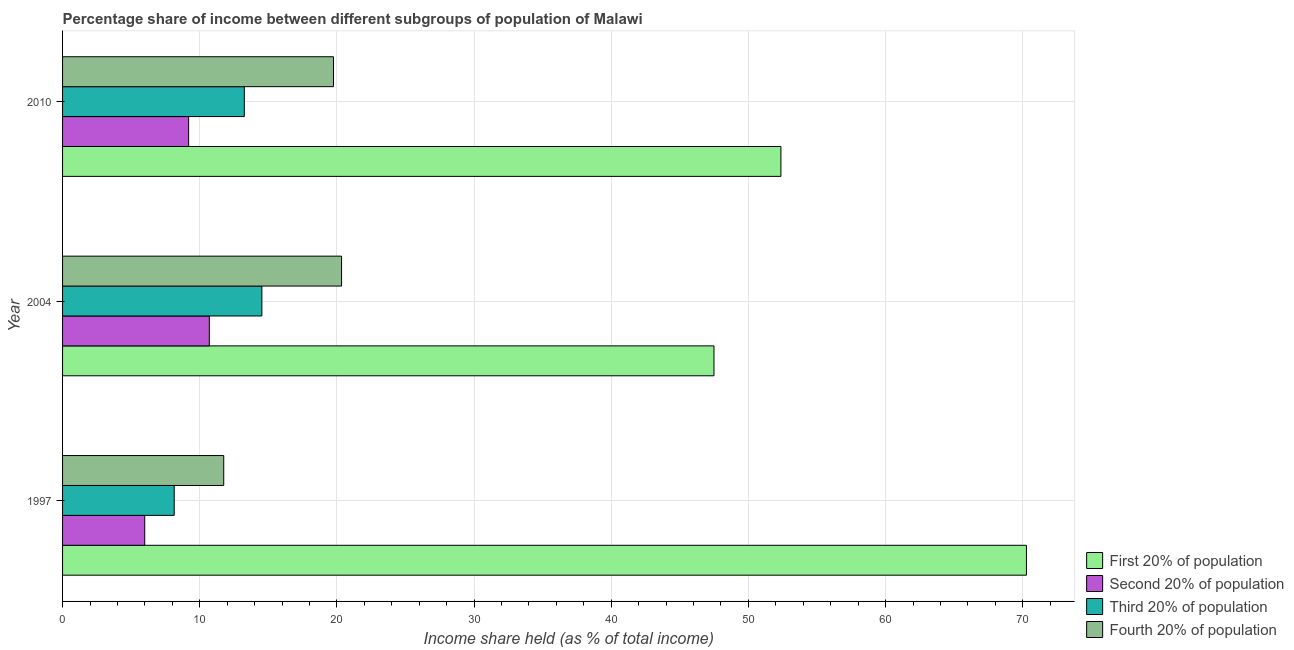How many different coloured bars are there?
Your response must be concise. 4. How many groups of bars are there?
Give a very brief answer. 3. How many bars are there on the 2nd tick from the top?
Offer a terse response. 4. How many bars are there on the 3rd tick from the bottom?
Your answer should be compact. 4. What is the share of the income held by fourth 20% of the population in 2004?
Your answer should be very brief. 20.34. Across all years, what is the maximum share of the income held by third 20% of the population?
Give a very brief answer. 14.53. Across all years, what is the minimum share of the income held by third 20% of the population?
Your answer should be very brief. 8.14. In which year was the share of the income held by first 20% of the population maximum?
Make the answer very short. 1997. What is the total share of the income held by first 20% of the population in the graph?
Ensure brevity in your answer.  170.13. What is the difference between the share of the income held by fourth 20% of the population in 2004 and that in 2010?
Ensure brevity in your answer.  0.59. What is the difference between the share of the income held by fourth 20% of the population in 1997 and the share of the income held by second 20% of the population in 2010?
Make the answer very short. 2.56. What is the average share of the income held by third 20% of the population per year?
Offer a terse response. 11.97. In the year 2010, what is the difference between the share of the income held by fourth 20% of the population and share of the income held by first 20% of the population?
Give a very brief answer. -32.62. What is the ratio of the share of the income held by fourth 20% of the population in 1997 to that in 2010?
Keep it short and to the point. 0.59. Is the share of the income held by first 20% of the population in 1997 less than that in 2010?
Your response must be concise. No. Is the difference between the share of the income held by fourth 20% of the population in 2004 and 2010 greater than the difference between the share of the income held by first 20% of the population in 2004 and 2010?
Offer a very short reply. Yes. What is the difference between the highest and the second highest share of the income held by third 20% of the population?
Your response must be concise. 1.28. What is the difference between the highest and the lowest share of the income held by fourth 20% of the population?
Ensure brevity in your answer.  8.59. Is the sum of the share of the income held by third 20% of the population in 2004 and 2010 greater than the maximum share of the income held by first 20% of the population across all years?
Your answer should be very brief. No. Is it the case that in every year, the sum of the share of the income held by fourth 20% of the population and share of the income held by third 20% of the population is greater than the sum of share of the income held by first 20% of the population and share of the income held by second 20% of the population?
Provide a succinct answer. No. What does the 4th bar from the top in 2010 represents?
Provide a short and direct response. First 20% of population. What does the 4th bar from the bottom in 2010 represents?
Your response must be concise. Fourth 20% of population. Are all the bars in the graph horizontal?
Your answer should be very brief. Yes. Does the graph contain grids?
Offer a very short reply. Yes. Where does the legend appear in the graph?
Offer a terse response. Bottom right. How are the legend labels stacked?
Offer a very short reply. Vertical. What is the title of the graph?
Your answer should be compact. Percentage share of income between different subgroups of population of Malawi. Does "France" appear as one of the legend labels in the graph?
Offer a terse response. No. What is the label or title of the X-axis?
Your answer should be very brief. Income share held (as % of total income). What is the Income share held (as % of total income) in First 20% of population in 1997?
Your response must be concise. 70.27. What is the Income share held (as % of total income) in Second 20% of population in 1997?
Offer a very short reply. 5.99. What is the Income share held (as % of total income) in Third 20% of population in 1997?
Offer a very short reply. 8.14. What is the Income share held (as % of total income) of Fourth 20% of population in 1997?
Offer a terse response. 11.75. What is the Income share held (as % of total income) of First 20% of population in 2004?
Keep it short and to the point. 47.49. What is the Income share held (as % of total income) in Second 20% of population in 2004?
Offer a terse response. 10.7. What is the Income share held (as % of total income) in Third 20% of population in 2004?
Keep it short and to the point. 14.53. What is the Income share held (as % of total income) of Fourth 20% of population in 2004?
Ensure brevity in your answer.  20.34. What is the Income share held (as % of total income) in First 20% of population in 2010?
Offer a very short reply. 52.37. What is the Income share held (as % of total income) in Second 20% of population in 2010?
Ensure brevity in your answer.  9.19. What is the Income share held (as % of total income) of Third 20% of population in 2010?
Offer a terse response. 13.25. What is the Income share held (as % of total income) of Fourth 20% of population in 2010?
Provide a succinct answer. 19.75. Across all years, what is the maximum Income share held (as % of total income) in First 20% of population?
Offer a terse response. 70.27. Across all years, what is the maximum Income share held (as % of total income) of Third 20% of population?
Provide a short and direct response. 14.53. Across all years, what is the maximum Income share held (as % of total income) of Fourth 20% of population?
Offer a very short reply. 20.34. Across all years, what is the minimum Income share held (as % of total income) of First 20% of population?
Keep it short and to the point. 47.49. Across all years, what is the minimum Income share held (as % of total income) in Second 20% of population?
Your answer should be compact. 5.99. Across all years, what is the minimum Income share held (as % of total income) of Third 20% of population?
Your response must be concise. 8.14. Across all years, what is the minimum Income share held (as % of total income) in Fourth 20% of population?
Make the answer very short. 11.75. What is the total Income share held (as % of total income) in First 20% of population in the graph?
Give a very brief answer. 170.13. What is the total Income share held (as % of total income) in Second 20% of population in the graph?
Your answer should be very brief. 25.88. What is the total Income share held (as % of total income) in Third 20% of population in the graph?
Your answer should be compact. 35.92. What is the total Income share held (as % of total income) in Fourth 20% of population in the graph?
Ensure brevity in your answer.  51.84. What is the difference between the Income share held (as % of total income) of First 20% of population in 1997 and that in 2004?
Provide a succinct answer. 22.78. What is the difference between the Income share held (as % of total income) of Second 20% of population in 1997 and that in 2004?
Your answer should be very brief. -4.71. What is the difference between the Income share held (as % of total income) of Third 20% of population in 1997 and that in 2004?
Your answer should be compact. -6.39. What is the difference between the Income share held (as % of total income) of Fourth 20% of population in 1997 and that in 2004?
Offer a very short reply. -8.59. What is the difference between the Income share held (as % of total income) in Second 20% of population in 1997 and that in 2010?
Provide a short and direct response. -3.2. What is the difference between the Income share held (as % of total income) of Third 20% of population in 1997 and that in 2010?
Ensure brevity in your answer.  -5.11. What is the difference between the Income share held (as % of total income) in Fourth 20% of population in 1997 and that in 2010?
Make the answer very short. -8. What is the difference between the Income share held (as % of total income) of First 20% of population in 2004 and that in 2010?
Make the answer very short. -4.88. What is the difference between the Income share held (as % of total income) in Second 20% of population in 2004 and that in 2010?
Offer a terse response. 1.51. What is the difference between the Income share held (as % of total income) in Third 20% of population in 2004 and that in 2010?
Your answer should be very brief. 1.28. What is the difference between the Income share held (as % of total income) of Fourth 20% of population in 2004 and that in 2010?
Your response must be concise. 0.59. What is the difference between the Income share held (as % of total income) in First 20% of population in 1997 and the Income share held (as % of total income) in Second 20% of population in 2004?
Keep it short and to the point. 59.57. What is the difference between the Income share held (as % of total income) of First 20% of population in 1997 and the Income share held (as % of total income) of Third 20% of population in 2004?
Your response must be concise. 55.74. What is the difference between the Income share held (as % of total income) in First 20% of population in 1997 and the Income share held (as % of total income) in Fourth 20% of population in 2004?
Offer a very short reply. 49.93. What is the difference between the Income share held (as % of total income) in Second 20% of population in 1997 and the Income share held (as % of total income) in Third 20% of population in 2004?
Your answer should be very brief. -8.54. What is the difference between the Income share held (as % of total income) in Second 20% of population in 1997 and the Income share held (as % of total income) in Fourth 20% of population in 2004?
Your answer should be compact. -14.35. What is the difference between the Income share held (as % of total income) in First 20% of population in 1997 and the Income share held (as % of total income) in Second 20% of population in 2010?
Provide a short and direct response. 61.08. What is the difference between the Income share held (as % of total income) in First 20% of population in 1997 and the Income share held (as % of total income) in Third 20% of population in 2010?
Your answer should be compact. 57.02. What is the difference between the Income share held (as % of total income) of First 20% of population in 1997 and the Income share held (as % of total income) of Fourth 20% of population in 2010?
Ensure brevity in your answer.  50.52. What is the difference between the Income share held (as % of total income) in Second 20% of population in 1997 and the Income share held (as % of total income) in Third 20% of population in 2010?
Provide a succinct answer. -7.26. What is the difference between the Income share held (as % of total income) in Second 20% of population in 1997 and the Income share held (as % of total income) in Fourth 20% of population in 2010?
Offer a terse response. -13.76. What is the difference between the Income share held (as % of total income) in Third 20% of population in 1997 and the Income share held (as % of total income) in Fourth 20% of population in 2010?
Offer a terse response. -11.61. What is the difference between the Income share held (as % of total income) in First 20% of population in 2004 and the Income share held (as % of total income) in Second 20% of population in 2010?
Your response must be concise. 38.3. What is the difference between the Income share held (as % of total income) in First 20% of population in 2004 and the Income share held (as % of total income) in Third 20% of population in 2010?
Give a very brief answer. 34.24. What is the difference between the Income share held (as % of total income) in First 20% of population in 2004 and the Income share held (as % of total income) in Fourth 20% of population in 2010?
Keep it short and to the point. 27.74. What is the difference between the Income share held (as % of total income) in Second 20% of population in 2004 and the Income share held (as % of total income) in Third 20% of population in 2010?
Provide a succinct answer. -2.55. What is the difference between the Income share held (as % of total income) of Second 20% of population in 2004 and the Income share held (as % of total income) of Fourth 20% of population in 2010?
Provide a succinct answer. -9.05. What is the difference between the Income share held (as % of total income) of Third 20% of population in 2004 and the Income share held (as % of total income) of Fourth 20% of population in 2010?
Offer a very short reply. -5.22. What is the average Income share held (as % of total income) in First 20% of population per year?
Offer a terse response. 56.71. What is the average Income share held (as % of total income) in Second 20% of population per year?
Offer a very short reply. 8.63. What is the average Income share held (as % of total income) in Third 20% of population per year?
Your answer should be very brief. 11.97. What is the average Income share held (as % of total income) in Fourth 20% of population per year?
Provide a succinct answer. 17.28. In the year 1997, what is the difference between the Income share held (as % of total income) in First 20% of population and Income share held (as % of total income) in Second 20% of population?
Offer a terse response. 64.28. In the year 1997, what is the difference between the Income share held (as % of total income) of First 20% of population and Income share held (as % of total income) of Third 20% of population?
Make the answer very short. 62.13. In the year 1997, what is the difference between the Income share held (as % of total income) in First 20% of population and Income share held (as % of total income) in Fourth 20% of population?
Offer a terse response. 58.52. In the year 1997, what is the difference between the Income share held (as % of total income) in Second 20% of population and Income share held (as % of total income) in Third 20% of population?
Offer a very short reply. -2.15. In the year 1997, what is the difference between the Income share held (as % of total income) of Second 20% of population and Income share held (as % of total income) of Fourth 20% of population?
Your answer should be very brief. -5.76. In the year 1997, what is the difference between the Income share held (as % of total income) in Third 20% of population and Income share held (as % of total income) in Fourth 20% of population?
Provide a short and direct response. -3.61. In the year 2004, what is the difference between the Income share held (as % of total income) of First 20% of population and Income share held (as % of total income) of Second 20% of population?
Give a very brief answer. 36.79. In the year 2004, what is the difference between the Income share held (as % of total income) of First 20% of population and Income share held (as % of total income) of Third 20% of population?
Give a very brief answer. 32.96. In the year 2004, what is the difference between the Income share held (as % of total income) in First 20% of population and Income share held (as % of total income) in Fourth 20% of population?
Your answer should be compact. 27.15. In the year 2004, what is the difference between the Income share held (as % of total income) in Second 20% of population and Income share held (as % of total income) in Third 20% of population?
Make the answer very short. -3.83. In the year 2004, what is the difference between the Income share held (as % of total income) of Second 20% of population and Income share held (as % of total income) of Fourth 20% of population?
Ensure brevity in your answer.  -9.64. In the year 2004, what is the difference between the Income share held (as % of total income) in Third 20% of population and Income share held (as % of total income) in Fourth 20% of population?
Your answer should be very brief. -5.81. In the year 2010, what is the difference between the Income share held (as % of total income) in First 20% of population and Income share held (as % of total income) in Second 20% of population?
Your answer should be very brief. 43.18. In the year 2010, what is the difference between the Income share held (as % of total income) in First 20% of population and Income share held (as % of total income) in Third 20% of population?
Ensure brevity in your answer.  39.12. In the year 2010, what is the difference between the Income share held (as % of total income) in First 20% of population and Income share held (as % of total income) in Fourth 20% of population?
Provide a short and direct response. 32.62. In the year 2010, what is the difference between the Income share held (as % of total income) of Second 20% of population and Income share held (as % of total income) of Third 20% of population?
Offer a very short reply. -4.06. In the year 2010, what is the difference between the Income share held (as % of total income) of Second 20% of population and Income share held (as % of total income) of Fourth 20% of population?
Your answer should be compact. -10.56. What is the ratio of the Income share held (as % of total income) of First 20% of population in 1997 to that in 2004?
Provide a short and direct response. 1.48. What is the ratio of the Income share held (as % of total income) of Second 20% of population in 1997 to that in 2004?
Give a very brief answer. 0.56. What is the ratio of the Income share held (as % of total income) in Third 20% of population in 1997 to that in 2004?
Offer a terse response. 0.56. What is the ratio of the Income share held (as % of total income) in Fourth 20% of population in 1997 to that in 2004?
Offer a terse response. 0.58. What is the ratio of the Income share held (as % of total income) of First 20% of population in 1997 to that in 2010?
Ensure brevity in your answer.  1.34. What is the ratio of the Income share held (as % of total income) of Second 20% of population in 1997 to that in 2010?
Make the answer very short. 0.65. What is the ratio of the Income share held (as % of total income) of Third 20% of population in 1997 to that in 2010?
Keep it short and to the point. 0.61. What is the ratio of the Income share held (as % of total income) in Fourth 20% of population in 1997 to that in 2010?
Your answer should be very brief. 0.59. What is the ratio of the Income share held (as % of total income) of First 20% of population in 2004 to that in 2010?
Provide a succinct answer. 0.91. What is the ratio of the Income share held (as % of total income) in Second 20% of population in 2004 to that in 2010?
Your response must be concise. 1.16. What is the ratio of the Income share held (as % of total income) in Third 20% of population in 2004 to that in 2010?
Ensure brevity in your answer.  1.1. What is the ratio of the Income share held (as % of total income) in Fourth 20% of population in 2004 to that in 2010?
Provide a succinct answer. 1.03. What is the difference between the highest and the second highest Income share held (as % of total income) of Second 20% of population?
Make the answer very short. 1.51. What is the difference between the highest and the second highest Income share held (as % of total income) in Third 20% of population?
Ensure brevity in your answer.  1.28. What is the difference between the highest and the second highest Income share held (as % of total income) of Fourth 20% of population?
Provide a succinct answer. 0.59. What is the difference between the highest and the lowest Income share held (as % of total income) in First 20% of population?
Offer a terse response. 22.78. What is the difference between the highest and the lowest Income share held (as % of total income) in Second 20% of population?
Keep it short and to the point. 4.71. What is the difference between the highest and the lowest Income share held (as % of total income) of Third 20% of population?
Ensure brevity in your answer.  6.39. What is the difference between the highest and the lowest Income share held (as % of total income) of Fourth 20% of population?
Offer a terse response. 8.59. 